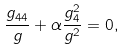Convert formula to latex. <formula><loc_0><loc_0><loc_500><loc_500>\frac { g _ { 4 4 } } { g } + \alpha \frac { g ^ { 2 } _ { 4 } } { g ^ { 2 } } = 0 ,</formula> 